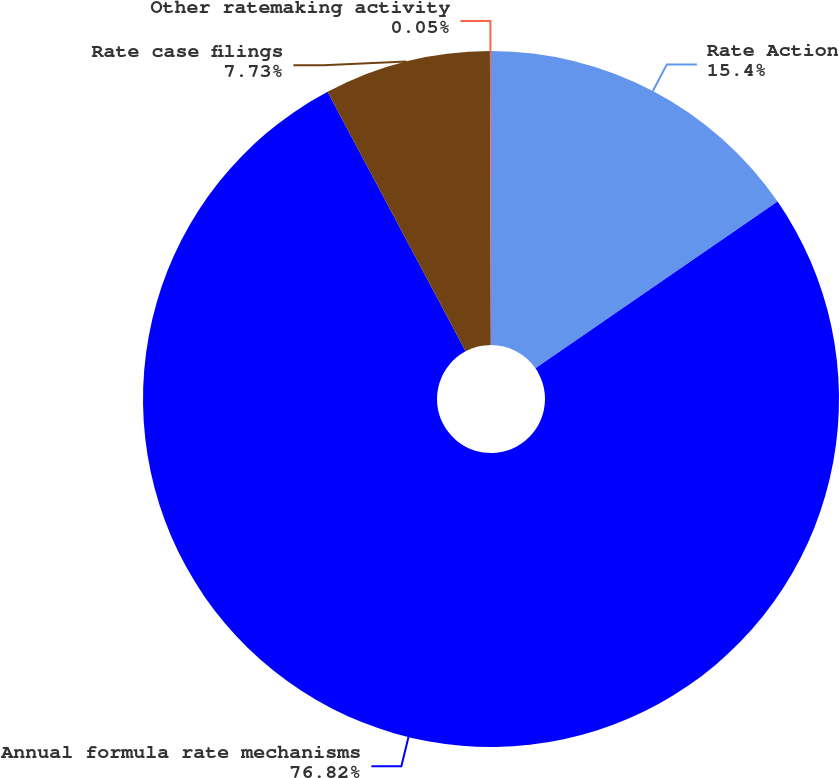<chart> <loc_0><loc_0><loc_500><loc_500><pie_chart><fcel>Rate Action<fcel>Annual formula rate mechanisms<fcel>Rate case filings<fcel>Other ratemaking activity<nl><fcel>15.4%<fcel>76.81%<fcel>7.73%<fcel>0.05%<nl></chart> 